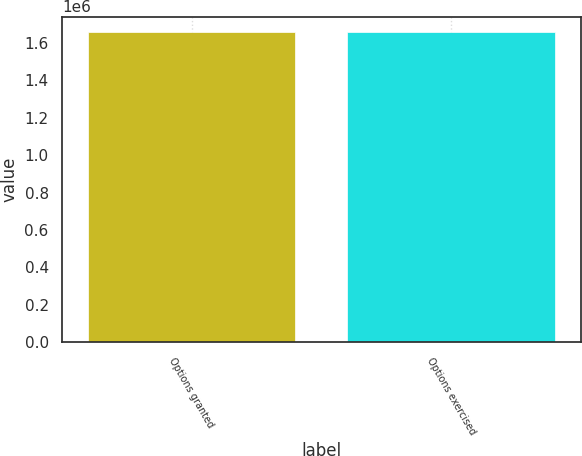<chart> <loc_0><loc_0><loc_500><loc_500><bar_chart><fcel>Options granted<fcel>Options exercised<nl><fcel>1.65655e+06<fcel>1.65655e+06<nl></chart> 